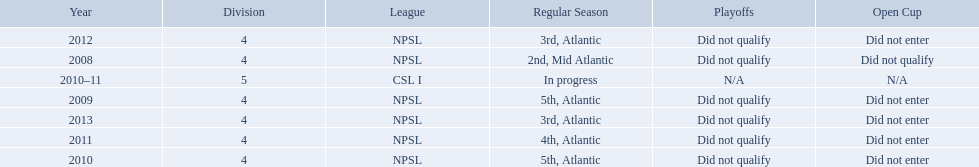What are all of the leagues? NPSL, NPSL, NPSL, CSL I, NPSL, NPSL, NPSL. Which league was played in the least? CSL I. Would you be able to parse every entry in this table? {'header': ['Year', 'Division', 'League', 'Regular Season', 'Playoffs', 'Open Cup'], 'rows': [['2012', '4', 'NPSL', '3rd, Atlantic', 'Did not qualify', 'Did not enter'], ['2008', '4', 'NPSL', '2nd, Mid Atlantic', 'Did not qualify', 'Did not qualify'], ['2010–11', '5', 'CSL I', 'In progress', 'N/A', 'N/A'], ['2009', '4', 'NPSL', '5th, Atlantic', 'Did not qualify', 'Did not enter'], ['2013', '4', 'NPSL', '3rd, Atlantic', 'Did not qualify', 'Did not enter'], ['2011', '4', 'NPSL', '4th, Atlantic', 'Did not qualify', 'Did not enter'], ['2010', '4', 'NPSL', '5th, Atlantic', 'Did not qualify', 'Did not enter']]} 